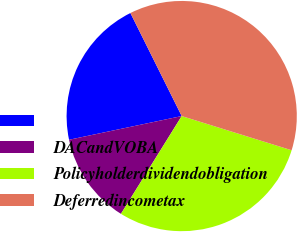Convert chart. <chart><loc_0><loc_0><loc_500><loc_500><pie_chart><ecel><fcel>DACandVOBA<fcel>Policyholderdividendobligation<fcel>Deferredincometax<nl><fcel>20.95%<fcel>12.85%<fcel>29.05%<fcel>37.15%<nl></chart> 